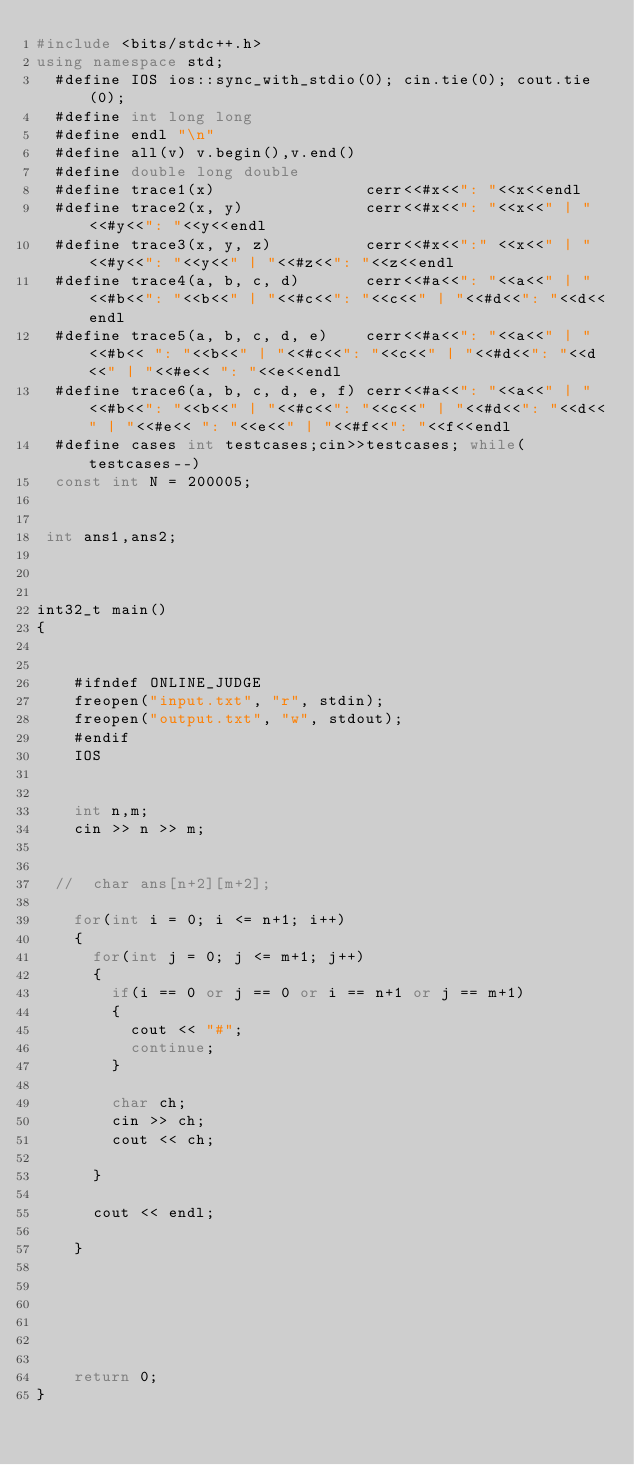<code> <loc_0><loc_0><loc_500><loc_500><_C++_>#include <bits/stdc++.h>
using namespace std;
  #define IOS ios::sync_with_stdio(0); cin.tie(0); cout.tie(0);
  #define int long long
  #define endl "\n"
  #define all(v) v.begin(),v.end()
  #define double long double
  #define trace1(x)                cerr<<#x<<": "<<x<<endl
  #define trace2(x, y)             cerr<<#x<<": "<<x<<" | "<<#y<<": "<<y<<endl
  #define trace3(x, y, z)          cerr<<#x<<":" <<x<<" | "<<#y<<": "<<y<<" | "<<#z<<": "<<z<<endl
  #define trace4(a, b, c, d)       cerr<<#a<<": "<<a<<" | "<<#b<<": "<<b<<" | "<<#c<<": "<<c<<" | "<<#d<<": "<<d<<endl
  #define trace5(a, b, c, d, e)    cerr<<#a<<": "<<a<<" | "<<#b<< ": "<<b<<" | "<<#c<<": "<<c<<" | "<<#d<<": "<<d<<" | "<<#e<< ": "<<e<<endl
  #define trace6(a, b, c, d, e, f) cerr<<#a<<": "<<a<<" | "<<#b<<": "<<b<<" | "<<#c<<": "<<c<<" | "<<#d<<": "<<d<<" | "<<#e<< ": "<<e<<" | "<<#f<<": "<<f<<endl
  #define cases int testcases;cin>>testcases; while(testcases--)
  const int N = 200005;


 int ans1,ans2;



int32_t main()
{


    #ifndef ONLINE_JUDGE
    freopen("input.txt", "r", stdin);
    freopen("output.txt", "w", stdout);
    #endif
    IOS

    
    int n,m;
    cin >> n >> m;


  //  char ans[n+2][m+2];

    for(int i = 0; i <= n+1; i++)
    {
      for(int j = 0; j <= m+1; j++)
      {
        if(i == 0 or j == 0 or i == n+1 or j == m+1)
        {
          cout << "#";
          continue;
        }

        char ch;
        cin >> ch;
        cout << ch;

      }

      cout << endl;

    }






    return 0;   
}
</code> 